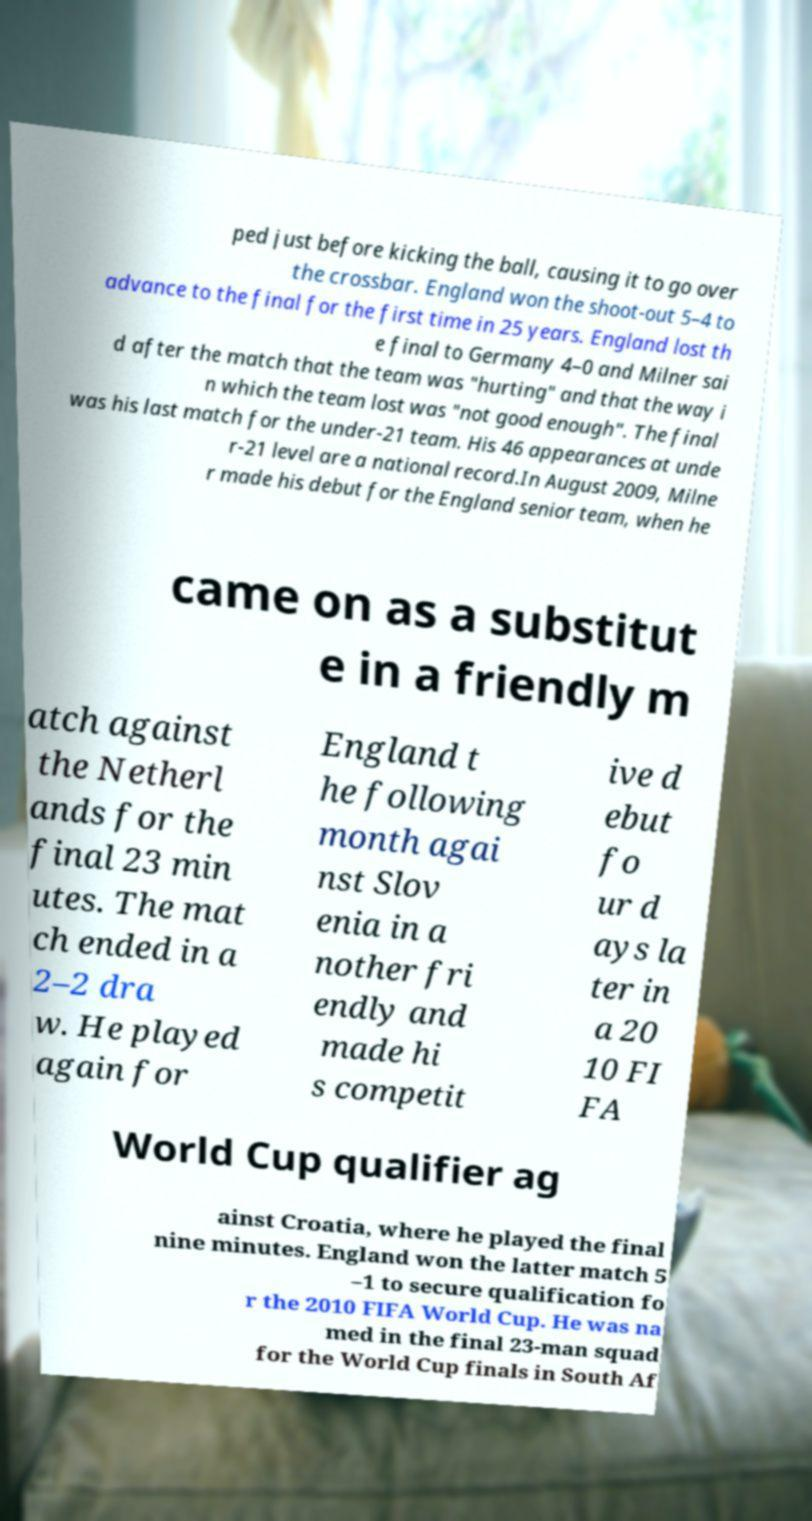Can you accurately transcribe the text from the provided image for me? ped just before kicking the ball, causing it to go over the crossbar. England won the shoot-out 5–4 to advance to the final for the first time in 25 years. England lost th e final to Germany 4–0 and Milner sai d after the match that the team was "hurting" and that the way i n which the team lost was "not good enough". The final was his last match for the under-21 team. His 46 appearances at unde r-21 level are a national record.In August 2009, Milne r made his debut for the England senior team, when he came on as a substitut e in a friendly m atch against the Netherl ands for the final 23 min utes. The mat ch ended in a 2–2 dra w. He played again for England t he following month agai nst Slov enia in a nother fri endly and made hi s competit ive d ebut fo ur d ays la ter in a 20 10 FI FA World Cup qualifier ag ainst Croatia, where he played the final nine minutes. England won the latter match 5 –1 to secure qualification fo r the 2010 FIFA World Cup. He was na med in the final 23-man squad for the World Cup finals in South Af 